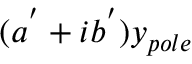<formula> <loc_0><loc_0><loc_500><loc_500>( a ^ { ^ { \prime } } + i b ^ { ^ { \prime } } ) y _ { p o l e }</formula> 